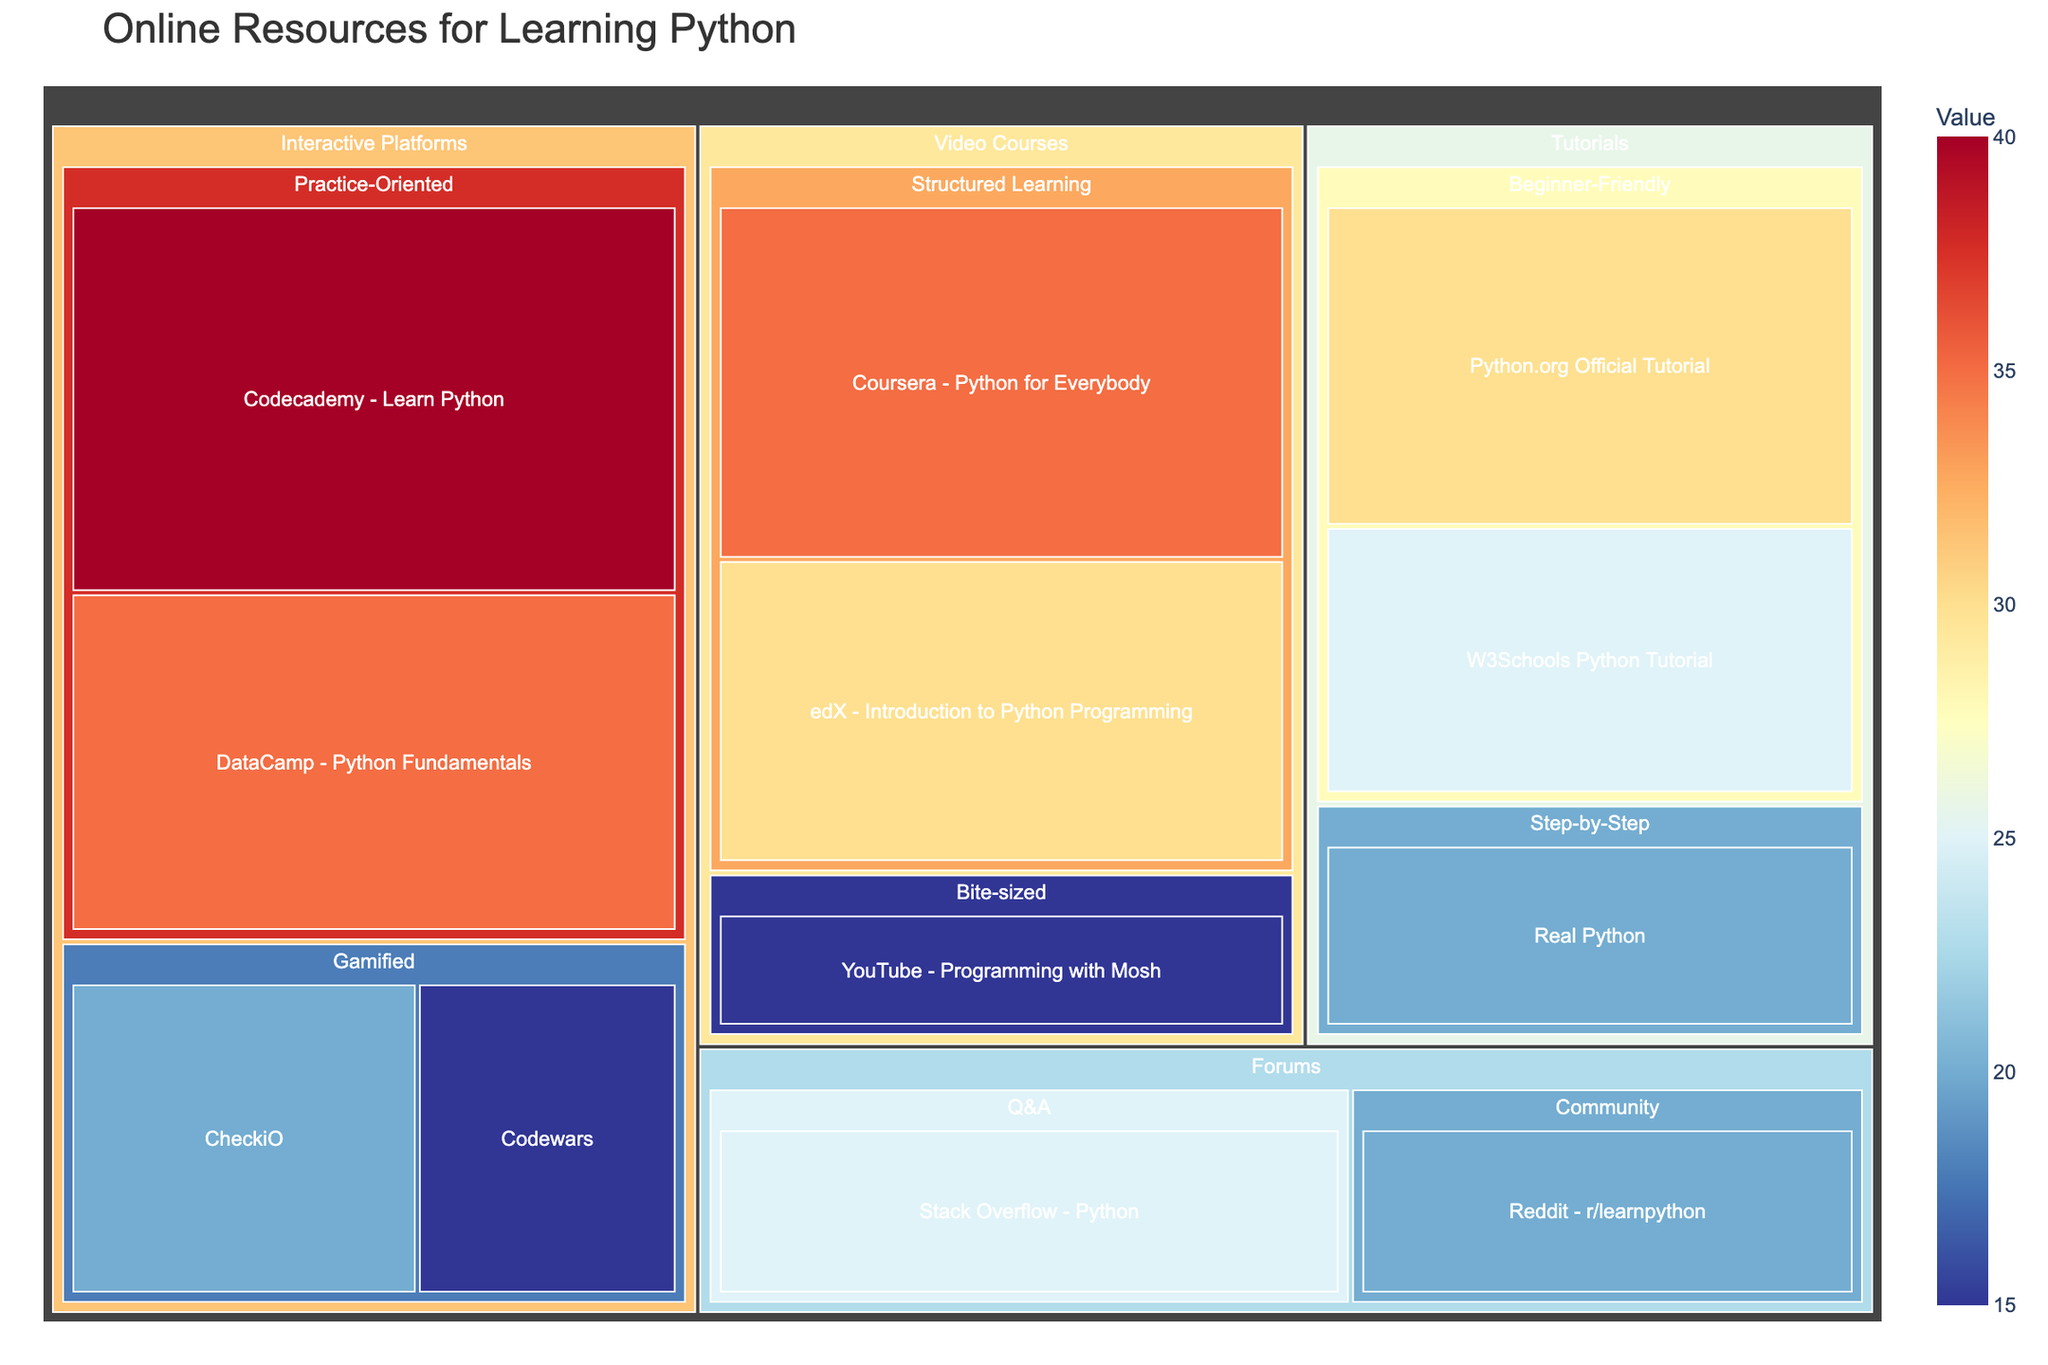what is the value of "Codecademy - Learn Python"? The "Codecademy - Learn Python" resource is under the "Interactive Platforms" category and "Practice-Oriented" subcategory. The value associated with this resource is displayed in the figure.
Answer: 40 Which subcategory has the highest total value within the "Interactive Platforms" category? Within the "Interactive Platforms" category, you need to sum the values of each subcategory. "Practice-Oriented": 40 (Codecademy) + 35 (DataCamp) = 75, "Gamified": 20 (CheckiO) + 15 (Codewars) = 35. The "Practice-Oriented" subcategory has the highest total value.
Answer: Practice-Oriented Compare the total value of resources under the "Video Courses" category and the "Tutorials" category. Which one is greater? Sum the values for each category: "Video Courses": 35 (Coursera) + 30 (edX) + 15 (YouTube) = 80, "Tutorials": 30 (Python.org) + 25 (W3Schools) + 20 (Real Python) = 75. The total value of "Video Courses" is greater.
Answer: Video Courses Which resource within the "Forums" category has the higher value? The "Forums" category includes "Stack Overflow - Python" with a value of 25 and "Reddit - r/learnpython" with a value of 20. Comparing these two, "Stack Overflow - Python" has the higher value.
Answer: Stack Overflow - Python What is the total value of all resources in the "Step-by-Step" subcategory? The "Step-by-Step" subcategory includes only one resource "Real Python" with a value of 20. Therefore, the total value is the same as the value of this single resource.
Answer: 20 How many resources are under the "Tutorials" category? The "Tutorials" category contains three resources: "Python.org Official Tutorial", "W3Schools Python Tutorial", and "Real Python". Simply count these resources.
Answer: 3 By how much does the value of "Coursera - Python for Everybody" exceed "YouTube - Programming with Mosh"? "Coursera - Python for Everybody" has a value of 35, and "YouTube - Programming with Mosh" has a value of 15. Subtract the smaller value from the larger one: 35 - 15 = 20.
Answer: 20 What is the sum of the values of all "Beginner-Friendly" resources under the "Tutorials" category? "Beginner-Friendly" subcategory includes "Python.org Official Tutorial" with a value of 30 and "W3Schools Python Tutorial" with a value of 25. Sum these values: 30 + 25 = 55.
Answer: 55 Which category contains resources with the lowest individual value? To find the lowest individual value, compare across all categories: "Video Courses" has a resource, "YouTube - Programming with Mosh" with a value of 15. This is the lowest individual value among all categories.
Answer: Video Courses What is the value range (difference between highest and lowest values) within the "Interactive Platforms" category? Identify the highest and lowest values in this category: Highest value is "Codecademy - Learn Python" with 40, lowest is "Codewars" with 15. Calculate the range as 40 - 15 = 25.
Answer: 25 